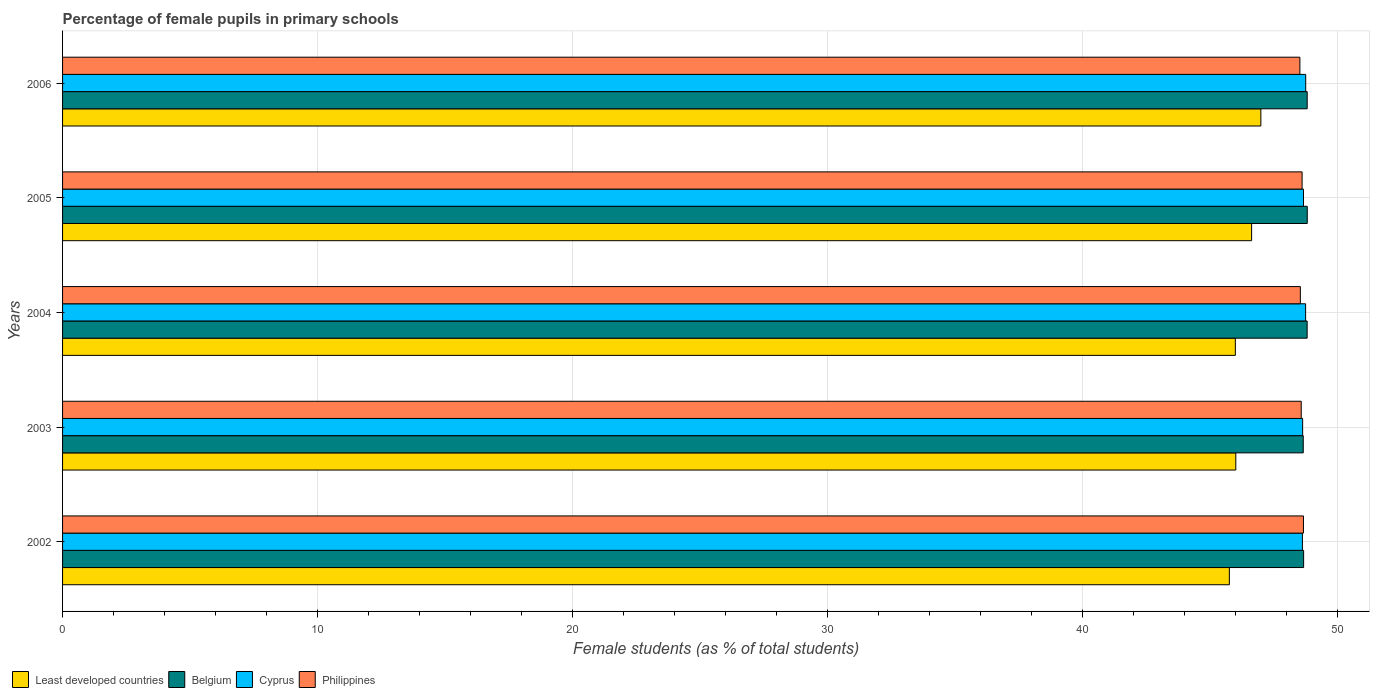How many different coloured bars are there?
Keep it short and to the point. 4. Are the number of bars per tick equal to the number of legend labels?
Offer a terse response. Yes. How many bars are there on the 4th tick from the top?
Give a very brief answer. 4. In how many cases, is the number of bars for a given year not equal to the number of legend labels?
Provide a succinct answer. 0. What is the percentage of female pupils in primary schools in Belgium in 2006?
Offer a terse response. 48.81. Across all years, what is the maximum percentage of female pupils in primary schools in Least developed countries?
Your answer should be very brief. 47. Across all years, what is the minimum percentage of female pupils in primary schools in Belgium?
Your answer should be very brief. 48.66. In which year was the percentage of female pupils in primary schools in Least developed countries maximum?
Provide a succinct answer. 2006. In which year was the percentage of female pupils in primary schools in Belgium minimum?
Offer a terse response. 2003. What is the total percentage of female pupils in primary schools in Belgium in the graph?
Your response must be concise. 243.77. What is the difference between the percentage of female pupils in primary schools in Least developed countries in 2003 and that in 2004?
Provide a short and direct response. 0.02. What is the difference between the percentage of female pupils in primary schools in Philippines in 2006 and the percentage of female pupils in primary schools in Belgium in 2005?
Offer a terse response. -0.29. What is the average percentage of female pupils in primary schools in Belgium per year?
Provide a succinct answer. 48.75. In the year 2003, what is the difference between the percentage of female pupils in primary schools in Least developed countries and percentage of female pupils in primary schools in Belgium?
Provide a succinct answer. -2.65. What is the ratio of the percentage of female pupils in primary schools in Belgium in 2002 to that in 2006?
Offer a terse response. 1. What is the difference between the highest and the second highest percentage of female pupils in primary schools in Philippines?
Provide a succinct answer. 0.05. What is the difference between the highest and the lowest percentage of female pupils in primary schools in Cyprus?
Your answer should be very brief. 0.13. In how many years, is the percentage of female pupils in primary schools in Least developed countries greater than the average percentage of female pupils in primary schools in Least developed countries taken over all years?
Your answer should be very brief. 2. Is it the case that in every year, the sum of the percentage of female pupils in primary schools in Least developed countries and percentage of female pupils in primary schools in Belgium is greater than the sum of percentage of female pupils in primary schools in Cyprus and percentage of female pupils in primary schools in Philippines?
Offer a terse response. No. What does the 4th bar from the bottom in 2006 represents?
Make the answer very short. Philippines. Is it the case that in every year, the sum of the percentage of female pupils in primary schools in Least developed countries and percentage of female pupils in primary schools in Philippines is greater than the percentage of female pupils in primary schools in Belgium?
Offer a terse response. Yes. How many bars are there?
Your answer should be compact. 20. What is the difference between two consecutive major ticks on the X-axis?
Provide a short and direct response. 10. Are the values on the major ticks of X-axis written in scientific E-notation?
Offer a very short reply. No. Does the graph contain any zero values?
Provide a short and direct response. No. Does the graph contain grids?
Provide a succinct answer. Yes. Where does the legend appear in the graph?
Your response must be concise. Bottom left. How many legend labels are there?
Keep it short and to the point. 4. How are the legend labels stacked?
Your response must be concise. Horizontal. What is the title of the graph?
Your response must be concise. Percentage of female pupils in primary schools. Does "Mauritania" appear as one of the legend labels in the graph?
Ensure brevity in your answer.  No. What is the label or title of the X-axis?
Provide a short and direct response. Female students (as % of total students). What is the label or title of the Y-axis?
Provide a succinct answer. Years. What is the Female students (as % of total students) of Least developed countries in 2002?
Your answer should be very brief. 45.76. What is the Female students (as % of total students) in Belgium in 2002?
Make the answer very short. 48.67. What is the Female students (as % of total students) of Cyprus in 2002?
Offer a very short reply. 48.62. What is the Female students (as % of total students) in Philippines in 2002?
Provide a short and direct response. 48.67. What is the Female students (as % of total students) of Least developed countries in 2003?
Provide a short and direct response. 46.01. What is the Female students (as % of total students) in Belgium in 2003?
Offer a terse response. 48.66. What is the Female students (as % of total students) in Cyprus in 2003?
Your answer should be very brief. 48.63. What is the Female students (as % of total students) in Philippines in 2003?
Provide a succinct answer. 48.58. What is the Female students (as % of total students) of Least developed countries in 2004?
Provide a succinct answer. 45.99. What is the Female students (as % of total students) of Belgium in 2004?
Offer a very short reply. 48.81. What is the Female students (as % of total students) of Cyprus in 2004?
Your response must be concise. 48.75. What is the Female students (as % of total students) of Philippines in 2004?
Your response must be concise. 48.54. What is the Female students (as % of total students) of Least developed countries in 2005?
Provide a succinct answer. 46.63. What is the Female students (as % of total students) in Belgium in 2005?
Your answer should be compact. 48.81. What is the Female students (as % of total students) in Cyprus in 2005?
Give a very brief answer. 48.67. What is the Female students (as % of total students) of Philippines in 2005?
Keep it short and to the point. 48.61. What is the Female students (as % of total students) of Least developed countries in 2006?
Provide a succinct answer. 47. What is the Female students (as % of total students) of Belgium in 2006?
Offer a very short reply. 48.81. What is the Female students (as % of total students) of Cyprus in 2006?
Your response must be concise. 48.75. What is the Female students (as % of total students) in Philippines in 2006?
Your answer should be compact. 48.53. Across all years, what is the maximum Female students (as % of total students) of Least developed countries?
Give a very brief answer. 47. Across all years, what is the maximum Female students (as % of total students) in Belgium?
Provide a succinct answer. 48.81. Across all years, what is the maximum Female students (as % of total students) of Cyprus?
Provide a succinct answer. 48.75. Across all years, what is the maximum Female students (as % of total students) of Philippines?
Your answer should be compact. 48.67. Across all years, what is the minimum Female students (as % of total students) in Least developed countries?
Provide a short and direct response. 45.76. Across all years, what is the minimum Female students (as % of total students) of Belgium?
Your response must be concise. 48.66. Across all years, what is the minimum Female students (as % of total students) in Cyprus?
Your answer should be compact. 48.62. Across all years, what is the minimum Female students (as % of total students) in Philippines?
Keep it short and to the point. 48.53. What is the total Female students (as % of total students) in Least developed countries in the graph?
Your answer should be compact. 231.39. What is the total Female students (as % of total students) in Belgium in the graph?
Ensure brevity in your answer.  243.77. What is the total Female students (as % of total students) of Cyprus in the graph?
Provide a short and direct response. 243.43. What is the total Female students (as % of total students) of Philippines in the graph?
Keep it short and to the point. 242.93. What is the difference between the Female students (as % of total students) of Least developed countries in 2002 and that in 2003?
Keep it short and to the point. -0.25. What is the difference between the Female students (as % of total students) of Belgium in 2002 and that in 2003?
Ensure brevity in your answer.  0.01. What is the difference between the Female students (as % of total students) in Cyprus in 2002 and that in 2003?
Your answer should be very brief. -0.01. What is the difference between the Female students (as % of total students) of Philippines in 2002 and that in 2003?
Provide a succinct answer. 0.09. What is the difference between the Female students (as % of total students) in Least developed countries in 2002 and that in 2004?
Keep it short and to the point. -0.23. What is the difference between the Female students (as % of total students) in Belgium in 2002 and that in 2004?
Provide a short and direct response. -0.14. What is the difference between the Female students (as % of total students) of Cyprus in 2002 and that in 2004?
Offer a very short reply. -0.13. What is the difference between the Female students (as % of total students) in Philippines in 2002 and that in 2004?
Your answer should be compact. 0.12. What is the difference between the Female students (as % of total students) in Least developed countries in 2002 and that in 2005?
Make the answer very short. -0.87. What is the difference between the Female students (as % of total students) of Belgium in 2002 and that in 2005?
Your response must be concise. -0.14. What is the difference between the Female students (as % of total students) of Cyprus in 2002 and that in 2005?
Ensure brevity in your answer.  -0.04. What is the difference between the Female students (as % of total students) of Philippines in 2002 and that in 2005?
Give a very brief answer. 0.05. What is the difference between the Female students (as % of total students) in Least developed countries in 2002 and that in 2006?
Keep it short and to the point. -1.24. What is the difference between the Female students (as % of total students) of Belgium in 2002 and that in 2006?
Ensure brevity in your answer.  -0.14. What is the difference between the Female students (as % of total students) of Cyprus in 2002 and that in 2006?
Offer a very short reply. -0.13. What is the difference between the Female students (as % of total students) in Philippines in 2002 and that in 2006?
Your response must be concise. 0.14. What is the difference between the Female students (as % of total students) in Least developed countries in 2003 and that in 2004?
Your response must be concise. 0.02. What is the difference between the Female students (as % of total students) in Belgium in 2003 and that in 2004?
Keep it short and to the point. -0.15. What is the difference between the Female students (as % of total students) in Cyprus in 2003 and that in 2004?
Keep it short and to the point. -0.12. What is the difference between the Female students (as % of total students) of Philippines in 2003 and that in 2004?
Make the answer very short. 0.04. What is the difference between the Female students (as % of total students) of Least developed countries in 2003 and that in 2005?
Your answer should be very brief. -0.62. What is the difference between the Female students (as % of total students) in Belgium in 2003 and that in 2005?
Provide a short and direct response. -0.16. What is the difference between the Female students (as % of total students) in Cyprus in 2003 and that in 2005?
Your answer should be very brief. -0.03. What is the difference between the Female students (as % of total students) in Philippines in 2003 and that in 2005?
Offer a very short reply. -0.03. What is the difference between the Female students (as % of total students) in Least developed countries in 2003 and that in 2006?
Make the answer very short. -0.98. What is the difference between the Female students (as % of total students) of Belgium in 2003 and that in 2006?
Offer a terse response. -0.15. What is the difference between the Female students (as % of total students) in Cyprus in 2003 and that in 2006?
Provide a succinct answer. -0.12. What is the difference between the Female students (as % of total students) of Philippines in 2003 and that in 2006?
Keep it short and to the point. 0.05. What is the difference between the Female students (as % of total students) of Least developed countries in 2004 and that in 2005?
Offer a very short reply. -0.64. What is the difference between the Female students (as % of total students) of Belgium in 2004 and that in 2005?
Offer a very short reply. -0. What is the difference between the Female students (as % of total students) in Cyprus in 2004 and that in 2005?
Your answer should be very brief. 0.08. What is the difference between the Female students (as % of total students) of Philippines in 2004 and that in 2005?
Your answer should be very brief. -0.07. What is the difference between the Female students (as % of total students) in Least developed countries in 2004 and that in 2006?
Offer a very short reply. -1. What is the difference between the Female students (as % of total students) in Belgium in 2004 and that in 2006?
Offer a terse response. -0. What is the difference between the Female students (as % of total students) in Cyprus in 2004 and that in 2006?
Your answer should be compact. -0. What is the difference between the Female students (as % of total students) of Philippines in 2004 and that in 2006?
Your answer should be compact. 0.02. What is the difference between the Female students (as % of total students) of Least developed countries in 2005 and that in 2006?
Provide a short and direct response. -0.36. What is the difference between the Female students (as % of total students) in Belgium in 2005 and that in 2006?
Your response must be concise. 0. What is the difference between the Female students (as % of total students) of Cyprus in 2005 and that in 2006?
Your response must be concise. -0.09. What is the difference between the Female students (as % of total students) of Philippines in 2005 and that in 2006?
Your answer should be very brief. 0.09. What is the difference between the Female students (as % of total students) of Least developed countries in 2002 and the Female students (as % of total students) of Belgium in 2003?
Your answer should be very brief. -2.9. What is the difference between the Female students (as % of total students) in Least developed countries in 2002 and the Female students (as % of total students) in Cyprus in 2003?
Offer a terse response. -2.87. What is the difference between the Female students (as % of total students) of Least developed countries in 2002 and the Female students (as % of total students) of Philippines in 2003?
Provide a short and direct response. -2.82. What is the difference between the Female students (as % of total students) of Belgium in 2002 and the Female students (as % of total students) of Cyprus in 2003?
Your answer should be compact. 0.04. What is the difference between the Female students (as % of total students) in Belgium in 2002 and the Female students (as % of total students) in Philippines in 2003?
Ensure brevity in your answer.  0.09. What is the difference between the Female students (as % of total students) in Cyprus in 2002 and the Female students (as % of total students) in Philippines in 2003?
Offer a terse response. 0.05. What is the difference between the Female students (as % of total students) in Least developed countries in 2002 and the Female students (as % of total students) in Belgium in 2004?
Your answer should be very brief. -3.05. What is the difference between the Female students (as % of total students) of Least developed countries in 2002 and the Female students (as % of total students) of Cyprus in 2004?
Offer a terse response. -2.99. What is the difference between the Female students (as % of total students) of Least developed countries in 2002 and the Female students (as % of total students) of Philippines in 2004?
Give a very brief answer. -2.78. What is the difference between the Female students (as % of total students) of Belgium in 2002 and the Female students (as % of total students) of Cyprus in 2004?
Offer a terse response. -0.08. What is the difference between the Female students (as % of total students) in Belgium in 2002 and the Female students (as % of total students) in Philippines in 2004?
Keep it short and to the point. 0.13. What is the difference between the Female students (as % of total students) of Cyprus in 2002 and the Female students (as % of total students) of Philippines in 2004?
Offer a terse response. 0.08. What is the difference between the Female students (as % of total students) of Least developed countries in 2002 and the Female students (as % of total students) of Belgium in 2005?
Offer a terse response. -3.06. What is the difference between the Female students (as % of total students) in Least developed countries in 2002 and the Female students (as % of total students) in Cyprus in 2005?
Make the answer very short. -2.91. What is the difference between the Female students (as % of total students) in Least developed countries in 2002 and the Female students (as % of total students) in Philippines in 2005?
Your answer should be very brief. -2.85. What is the difference between the Female students (as % of total students) in Belgium in 2002 and the Female students (as % of total students) in Cyprus in 2005?
Offer a very short reply. 0.01. What is the difference between the Female students (as % of total students) of Belgium in 2002 and the Female students (as % of total students) of Philippines in 2005?
Give a very brief answer. 0.06. What is the difference between the Female students (as % of total students) of Cyprus in 2002 and the Female students (as % of total students) of Philippines in 2005?
Your answer should be compact. 0.01. What is the difference between the Female students (as % of total students) in Least developed countries in 2002 and the Female students (as % of total students) in Belgium in 2006?
Your response must be concise. -3.05. What is the difference between the Female students (as % of total students) of Least developed countries in 2002 and the Female students (as % of total students) of Cyprus in 2006?
Keep it short and to the point. -2.99. What is the difference between the Female students (as % of total students) in Least developed countries in 2002 and the Female students (as % of total students) in Philippines in 2006?
Provide a succinct answer. -2.77. What is the difference between the Female students (as % of total students) in Belgium in 2002 and the Female students (as % of total students) in Cyprus in 2006?
Your response must be concise. -0.08. What is the difference between the Female students (as % of total students) of Belgium in 2002 and the Female students (as % of total students) of Philippines in 2006?
Your answer should be very brief. 0.15. What is the difference between the Female students (as % of total students) in Cyprus in 2002 and the Female students (as % of total students) in Philippines in 2006?
Provide a short and direct response. 0.1. What is the difference between the Female students (as % of total students) of Least developed countries in 2003 and the Female students (as % of total students) of Belgium in 2004?
Offer a very short reply. -2.8. What is the difference between the Female students (as % of total students) in Least developed countries in 2003 and the Female students (as % of total students) in Cyprus in 2004?
Offer a terse response. -2.74. What is the difference between the Female students (as % of total students) of Least developed countries in 2003 and the Female students (as % of total students) of Philippines in 2004?
Offer a very short reply. -2.53. What is the difference between the Female students (as % of total students) in Belgium in 2003 and the Female students (as % of total students) in Cyprus in 2004?
Ensure brevity in your answer.  -0.09. What is the difference between the Female students (as % of total students) of Belgium in 2003 and the Female students (as % of total students) of Philippines in 2004?
Provide a succinct answer. 0.11. What is the difference between the Female students (as % of total students) in Cyprus in 2003 and the Female students (as % of total students) in Philippines in 2004?
Your answer should be compact. 0.09. What is the difference between the Female students (as % of total students) in Least developed countries in 2003 and the Female students (as % of total students) in Belgium in 2005?
Offer a terse response. -2.8. What is the difference between the Female students (as % of total students) in Least developed countries in 2003 and the Female students (as % of total students) in Cyprus in 2005?
Ensure brevity in your answer.  -2.65. What is the difference between the Female students (as % of total students) in Belgium in 2003 and the Female students (as % of total students) in Cyprus in 2005?
Offer a very short reply. -0.01. What is the difference between the Female students (as % of total students) of Belgium in 2003 and the Female students (as % of total students) of Philippines in 2005?
Your answer should be very brief. 0.05. What is the difference between the Female students (as % of total students) in Cyprus in 2003 and the Female students (as % of total students) in Philippines in 2005?
Ensure brevity in your answer.  0.02. What is the difference between the Female students (as % of total students) of Least developed countries in 2003 and the Female students (as % of total students) of Belgium in 2006?
Offer a terse response. -2.8. What is the difference between the Female students (as % of total students) in Least developed countries in 2003 and the Female students (as % of total students) in Cyprus in 2006?
Give a very brief answer. -2.74. What is the difference between the Female students (as % of total students) in Least developed countries in 2003 and the Female students (as % of total students) in Philippines in 2006?
Your response must be concise. -2.51. What is the difference between the Female students (as % of total students) in Belgium in 2003 and the Female students (as % of total students) in Cyprus in 2006?
Make the answer very short. -0.1. What is the difference between the Female students (as % of total students) of Belgium in 2003 and the Female students (as % of total students) of Philippines in 2006?
Your answer should be compact. 0.13. What is the difference between the Female students (as % of total students) in Cyprus in 2003 and the Female students (as % of total students) in Philippines in 2006?
Your answer should be very brief. 0.11. What is the difference between the Female students (as % of total students) of Least developed countries in 2004 and the Female students (as % of total students) of Belgium in 2005?
Make the answer very short. -2.82. What is the difference between the Female students (as % of total students) in Least developed countries in 2004 and the Female students (as % of total students) in Cyprus in 2005?
Make the answer very short. -2.67. What is the difference between the Female students (as % of total students) of Least developed countries in 2004 and the Female students (as % of total students) of Philippines in 2005?
Make the answer very short. -2.62. What is the difference between the Female students (as % of total students) of Belgium in 2004 and the Female students (as % of total students) of Cyprus in 2005?
Your answer should be very brief. 0.14. What is the difference between the Female students (as % of total students) in Belgium in 2004 and the Female students (as % of total students) in Philippines in 2005?
Offer a very short reply. 0.2. What is the difference between the Female students (as % of total students) in Cyprus in 2004 and the Female students (as % of total students) in Philippines in 2005?
Offer a terse response. 0.14. What is the difference between the Female students (as % of total students) of Least developed countries in 2004 and the Female students (as % of total students) of Belgium in 2006?
Provide a short and direct response. -2.82. What is the difference between the Female students (as % of total students) in Least developed countries in 2004 and the Female students (as % of total students) in Cyprus in 2006?
Make the answer very short. -2.76. What is the difference between the Female students (as % of total students) of Least developed countries in 2004 and the Female students (as % of total students) of Philippines in 2006?
Offer a terse response. -2.53. What is the difference between the Female students (as % of total students) of Belgium in 2004 and the Female students (as % of total students) of Cyprus in 2006?
Offer a very short reply. 0.06. What is the difference between the Female students (as % of total students) in Belgium in 2004 and the Female students (as % of total students) in Philippines in 2006?
Keep it short and to the point. 0.28. What is the difference between the Female students (as % of total students) in Cyprus in 2004 and the Female students (as % of total students) in Philippines in 2006?
Ensure brevity in your answer.  0.22. What is the difference between the Female students (as % of total students) of Least developed countries in 2005 and the Female students (as % of total students) of Belgium in 2006?
Offer a terse response. -2.18. What is the difference between the Female students (as % of total students) in Least developed countries in 2005 and the Female students (as % of total students) in Cyprus in 2006?
Your answer should be very brief. -2.12. What is the difference between the Female students (as % of total students) of Least developed countries in 2005 and the Female students (as % of total students) of Philippines in 2006?
Offer a terse response. -1.89. What is the difference between the Female students (as % of total students) in Belgium in 2005 and the Female students (as % of total students) in Cyprus in 2006?
Give a very brief answer. 0.06. What is the difference between the Female students (as % of total students) in Belgium in 2005 and the Female students (as % of total students) in Philippines in 2006?
Your answer should be compact. 0.29. What is the difference between the Female students (as % of total students) in Cyprus in 2005 and the Female students (as % of total students) in Philippines in 2006?
Ensure brevity in your answer.  0.14. What is the average Female students (as % of total students) in Least developed countries per year?
Your answer should be compact. 46.28. What is the average Female students (as % of total students) in Belgium per year?
Make the answer very short. 48.75. What is the average Female students (as % of total students) in Cyprus per year?
Your answer should be very brief. 48.69. What is the average Female students (as % of total students) in Philippines per year?
Offer a terse response. 48.59. In the year 2002, what is the difference between the Female students (as % of total students) of Least developed countries and Female students (as % of total students) of Belgium?
Your response must be concise. -2.91. In the year 2002, what is the difference between the Female students (as % of total students) in Least developed countries and Female students (as % of total students) in Cyprus?
Your answer should be very brief. -2.86. In the year 2002, what is the difference between the Female students (as % of total students) in Least developed countries and Female students (as % of total students) in Philippines?
Keep it short and to the point. -2.91. In the year 2002, what is the difference between the Female students (as % of total students) in Belgium and Female students (as % of total students) in Cyprus?
Your response must be concise. 0.05. In the year 2002, what is the difference between the Female students (as % of total students) of Belgium and Female students (as % of total students) of Philippines?
Offer a terse response. 0.01. In the year 2002, what is the difference between the Female students (as % of total students) in Cyprus and Female students (as % of total students) in Philippines?
Offer a very short reply. -0.04. In the year 2003, what is the difference between the Female students (as % of total students) in Least developed countries and Female students (as % of total students) in Belgium?
Provide a succinct answer. -2.65. In the year 2003, what is the difference between the Female students (as % of total students) of Least developed countries and Female students (as % of total students) of Cyprus?
Provide a succinct answer. -2.62. In the year 2003, what is the difference between the Female students (as % of total students) of Least developed countries and Female students (as % of total students) of Philippines?
Your response must be concise. -2.57. In the year 2003, what is the difference between the Female students (as % of total students) in Belgium and Female students (as % of total students) in Cyprus?
Provide a short and direct response. 0.02. In the year 2003, what is the difference between the Female students (as % of total students) of Belgium and Female students (as % of total students) of Philippines?
Provide a short and direct response. 0.08. In the year 2003, what is the difference between the Female students (as % of total students) of Cyprus and Female students (as % of total students) of Philippines?
Ensure brevity in your answer.  0.06. In the year 2004, what is the difference between the Female students (as % of total students) in Least developed countries and Female students (as % of total students) in Belgium?
Provide a succinct answer. -2.82. In the year 2004, what is the difference between the Female students (as % of total students) of Least developed countries and Female students (as % of total students) of Cyprus?
Provide a succinct answer. -2.76. In the year 2004, what is the difference between the Female students (as % of total students) in Least developed countries and Female students (as % of total students) in Philippines?
Ensure brevity in your answer.  -2.55. In the year 2004, what is the difference between the Female students (as % of total students) of Belgium and Female students (as % of total students) of Cyprus?
Your answer should be compact. 0.06. In the year 2004, what is the difference between the Female students (as % of total students) of Belgium and Female students (as % of total students) of Philippines?
Ensure brevity in your answer.  0.27. In the year 2004, what is the difference between the Female students (as % of total students) of Cyprus and Female students (as % of total students) of Philippines?
Your answer should be very brief. 0.21. In the year 2005, what is the difference between the Female students (as % of total students) of Least developed countries and Female students (as % of total students) of Belgium?
Keep it short and to the point. -2.18. In the year 2005, what is the difference between the Female students (as % of total students) in Least developed countries and Female students (as % of total students) in Cyprus?
Offer a terse response. -2.03. In the year 2005, what is the difference between the Female students (as % of total students) in Least developed countries and Female students (as % of total students) in Philippines?
Give a very brief answer. -1.98. In the year 2005, what is the difference between the Female students (as % of total students) in Belgium and Female students (as % of total students) in Cyprus?
Offer a terse response. 0.15. In the year 2005, what is the difference between the Female students (as % of total students) in Belgium and Female students (as % of total students) in Philippines?
Offer a very short reply. 0.2. In the year 2005, what is the difference between the Female students (as % of total students) in Cyprus and Female students (as % of total students) in Philippines?
Provide a succinct answer. 0.05. In the year 2006, what is the difference between the Female students (as % of total students) in Least developed countries and Female students (as % of total students) in Belgium?
Your answer should be compact. -1.82. In the year 2006, what is the difference between the Female students (as % of total students) of Least developed countries and Female students (as % of total students) of Cyprus?
Provide a succinct answer. -1.76. In the year 2006, what is the difference between the Female students (as % of total students) in Least developed countries and Female students (as % of total students) in Philippines?
Make the answer very short. -1.53. In the year 2006, what is the difference between the Female students (as % of total students) in Belgium and Female students (as % of total students) in Cyprus?
Provide a short and direct response. 0.06. In the year 2006, what is the difference between the Female students (as % of total students) in Belgium and Female students (as % of total students) in Philippines?
Provide a short and direct response. 0.29. In the year 2006, what is the difference between the Female students (as % of total students) of Cyprus and Female students (as % of total students) of Philippines?
Your answer should be compact. 0.23. What is the ratio of the Female students (as % of total students) in Belgium in 2002 to that in 2003?
Your response must be concise. 1. What is the ratio of the Female students (as % of total students) in Philippines in 2002 to that in 2003?
Ensure brevity in your answer.  1. What is the ratio of the Female students (as % of total students) in Least developed countries in 2002 to that in 2004?
Provide a succinct answer. 0.99. What is the ratio of the Female students (as % of total students) of Belgium in 2002 to that in 2004?
Your answer should be compact. 1. What is the ratio of the Female students (as % of total students) of Cyprus in 2002 to that in 2004?
Provide a short and direct response. 1. What is the ratio of the Female students (as % of total students) in Least developed countries in 2002 to that in 2005?
Make the answer very short. 0.98. What is the ratio of the Female students (as % of total students) of Least developed countries in 2002 to that in 2006?
Offer a terse response. 0.97. What is the ratio of the Female students (as % of total students) of Cyprus in 2002 to that in 2006?
Offer a terse response. 1. What is the ratio of the Female students (as % of total students) of Least developed countries in 2003 to that in 2004?
Make the answer very short. 1. What is the ratio of the Female students (as % of total students) of Cyprus in 2003 to that in 2004?
Your answer should be very brief. 1. What is the ratio of the Female students (as % of total students) in Philippines in 2003 to that in 2004?
Offer a terse response. 1. What is the ratio of the Female students (as % of total students) of Least developed countries in 2003 to that in 2005?
Your answer should be compact. 0.99. What is the ratio of the Female students (as % of total students) in Philippines in 2003 to that in 2005?
Offer a very short reply. 1. What is the ratio of the Female students (as % of total students) of Least developed countries in 2003 to that in 2006?
Offer a very short reply. 0.98. What is the ratio of the Female students (as % of total students) of Cyprus in 2003 to that in 2006?
Your answer should be compact. 1. What is the ratio of the Female students (as % of total students) in Philippines in 2003 to that in 2006?
Provide a short and direct response. 1. What is the ratio of the Female students (as % of total students) of Least developed countries in 2004 to that in 2005?
Your answer should be compact. 0.99. What is the ratio of the Female students (as % of total students) of Belgium in 2004 to that in 2005?
Provide a succinct answer. 1. What is the ratio of the Female students (as % of total students) in Philippines in 2004 to that in 2005?
Ensure brevity in your answer.  1. What is the ratio of the Female students (as % of total students) in Least developed countries in 2004 to that in 2006?
Give a very brief answer. 0.98. What is the ratio of the Female students (as % of total students) in Philippines in 2004 to that in 2006?
Ensure brevity in your answer.  1. What is the ratio of the Female students (as % of total students) in Belgium in 2005 to that in 2006?
Your response must be concise. 1. What is the difference between the highest and the second highest Female students (as % of total students) in Least developed countries?
Offer a very short reply. 0.36. What is the difference between the highest and the second highest Female students (as % of total students) in Belgium?
Provide a succinct answer. 0. What is the difference between the highest and the second highest Female students (as % of total students) in Cyprus?
Your answer should be very brief. 0. What is the difference between the highest and the second highest Female students (as % of total students) of Philippines?
Keep it short and to the point. 0.05. What is the difference between the highest and the lowest Female students (as % of total students) of Least developed countries?
Provide a succinct answer. 1.24. What is the difference between the highest and the lowest Female students (as % of total students) of Belgium?
Your answer should be compact. 0.16. What is the difference between the highest and the lowest Female students (as % of total students) of Cyprus?
Keep it short and to the point. 0.13. What is the difference between the highest and the lowest Female students (as % of total students) in Philippines?
Offer a very short reply. 0.14. 